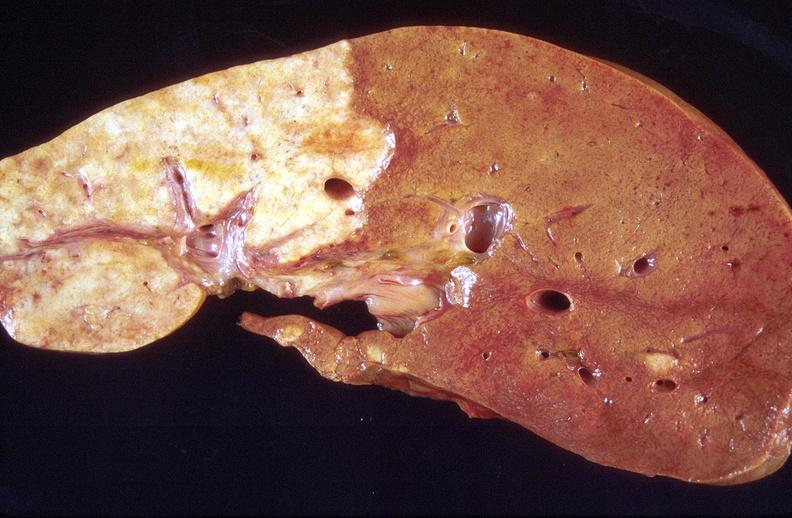what is present?
Answer the question using a single word or phrase. Hepatobiliary 